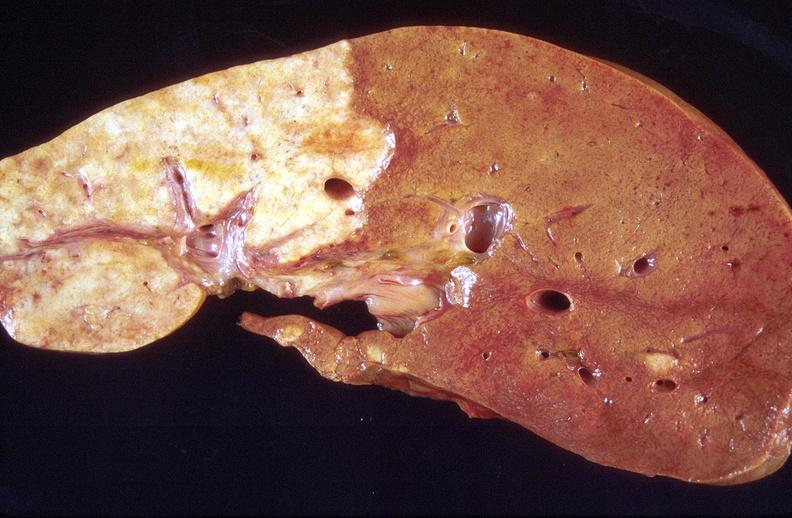what is present?
Answer the question using a single word or phrase. Hepatobiliary 